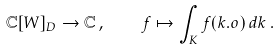Convert formula to latex. <formula><loc_0><loc_0><loc_500><loc_500>\mathbb { C } [ W ] _ { D } \to \mathbb { C } \, , \quad f \mapsto \int _ { K } f ( k . o ) \, d k \, .</formula> 